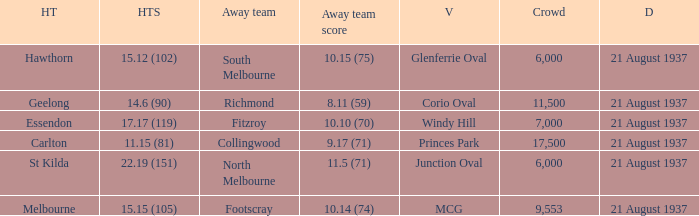Where does South Melbourne play? Glenferrie Oval. 